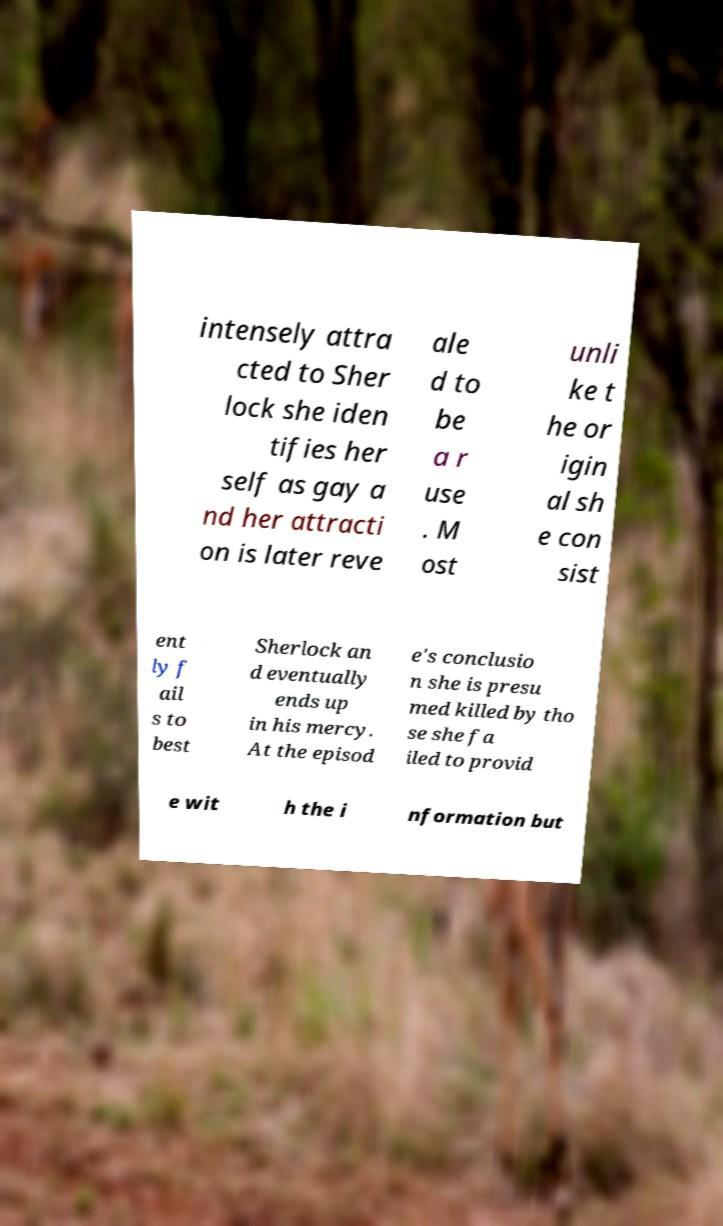Could you assist in decoding the text presented in this image and type it out clearly? intensely attra cted to Sher lock she iden tifies her self as gay a nd her attracti on is later reve ale d to be a r use . M ost unli ke t he or igin al sh e con sist ent ly f ail s to best Sherlock an d eventually ends up in his mercy. At the episod e's conclusio n she is presu med killed by tho se she fa iled to provid e wit h the i nformation but 